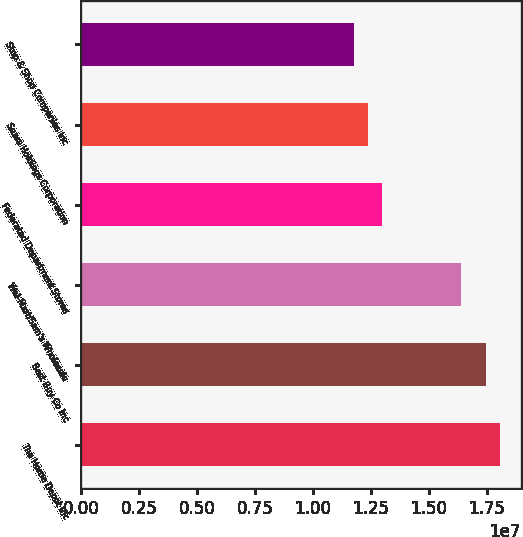Convert chart. <chart><loc_0><loc_0><loc_500><loc_500><bar_chart><fcel>The Home Depot Inc<fcel>Best Buy Co Inc<fcel>Wal-Mart/Sam's Wholesale<fcel>Federated Department Stores<fcel>Sears Holdings Corporation<fcel>Stop & Shop Companies Inc<nl><fcel>1.80833e+07<fcel>1.7486e+07<fcel>1.6417e+07<fcel>1.29876e+07<fcel>1.23903e+07<fcel>1.1793e+07<nl></chart> 